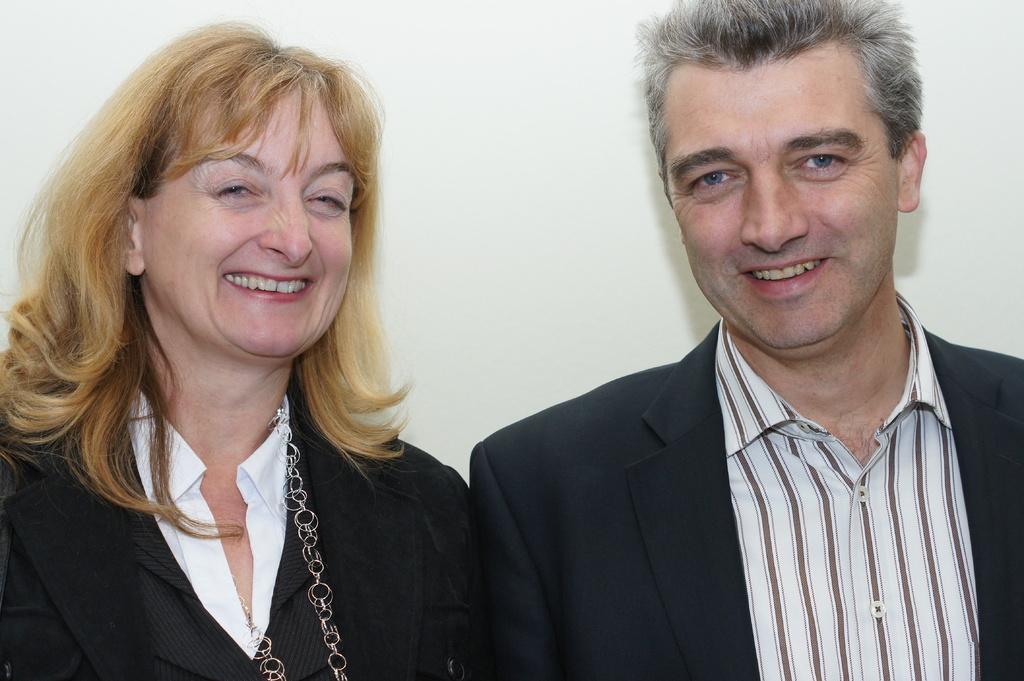How would you summarize this image in a sentence or two? In this picture we can see a man and woman and they both are smiling. 